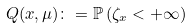Convert formula to latex. <formula><loc_0><loc_0><loc_500><loc_500>Q ( x , \mu ) \colon = \mathbb { P } \left ( \zeta _ { x } < + \infty \right )</formula> 